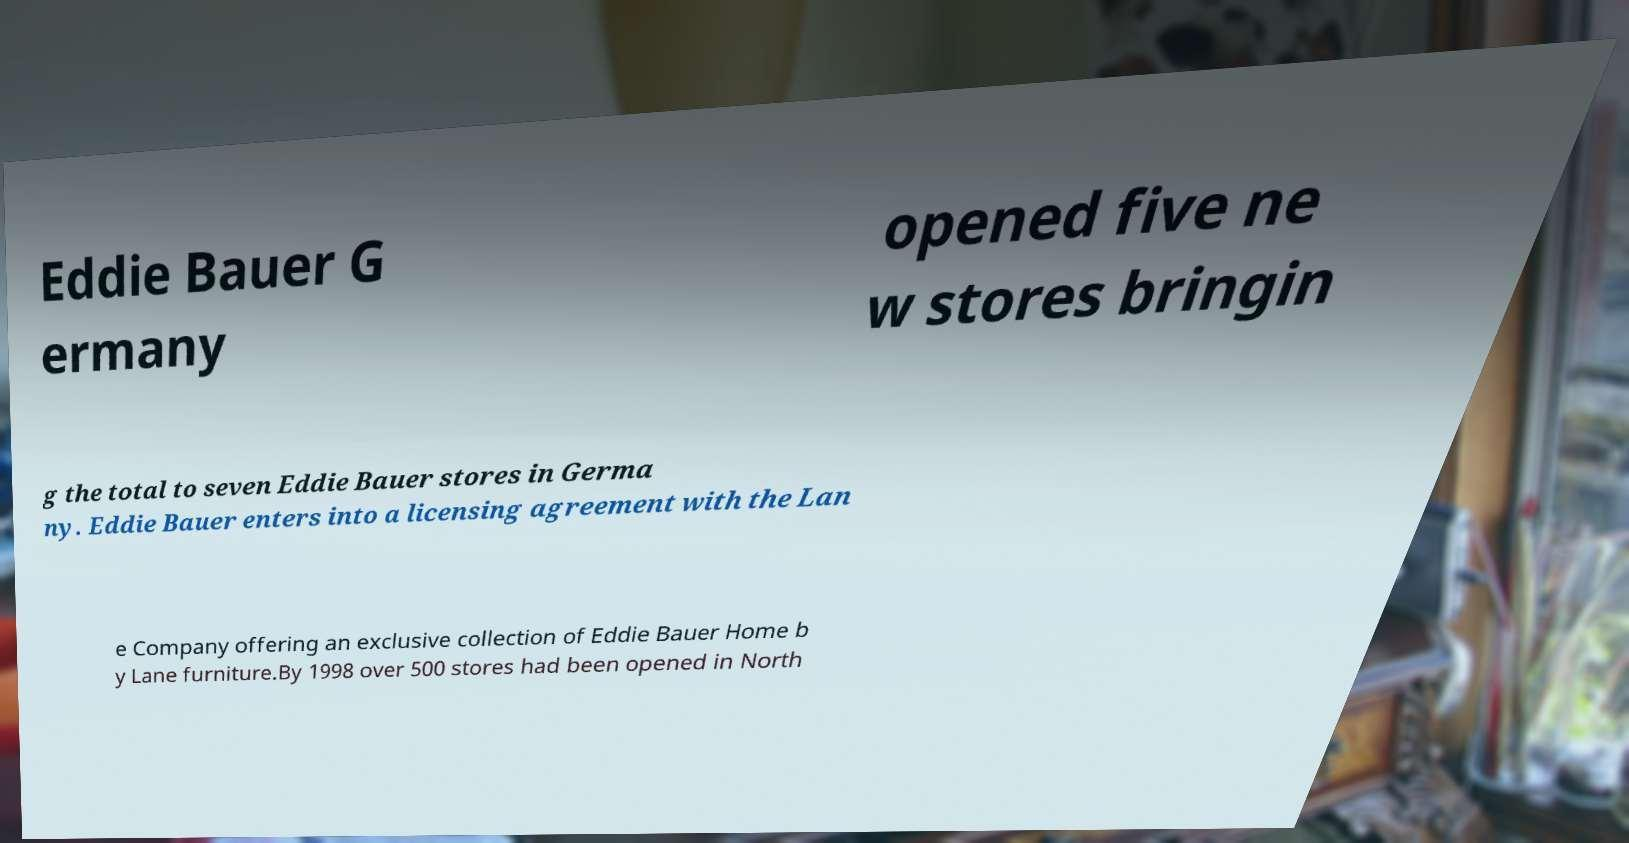What messages or text are displayed in this image? I need them in a readable, typed format. Eddie Bauer G ermany opened five ne w stores bringin g the total to seven Eddie Bauer stores in Germa ny. Eddie Bauer enters into a licensing agreement with the Lan e Company offering an exclusive collection of Eddie Bauer Home b y Lane furniture.By 1998 over 500 stores had been opened in North 